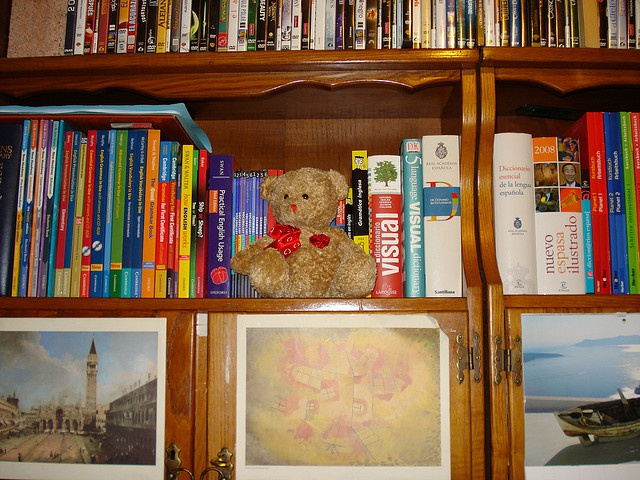Describe the objects in this image and their specific colors. I can see book in black, navy, tan, and brown tones, teddy bear in black, olive, tan, and maroon tones, book in black, lightgray, tan, red, and darkgray tones, book in black, tan, darkgray, and lightgray tones, and book in black, brown, maroon, and red tones in this image. 